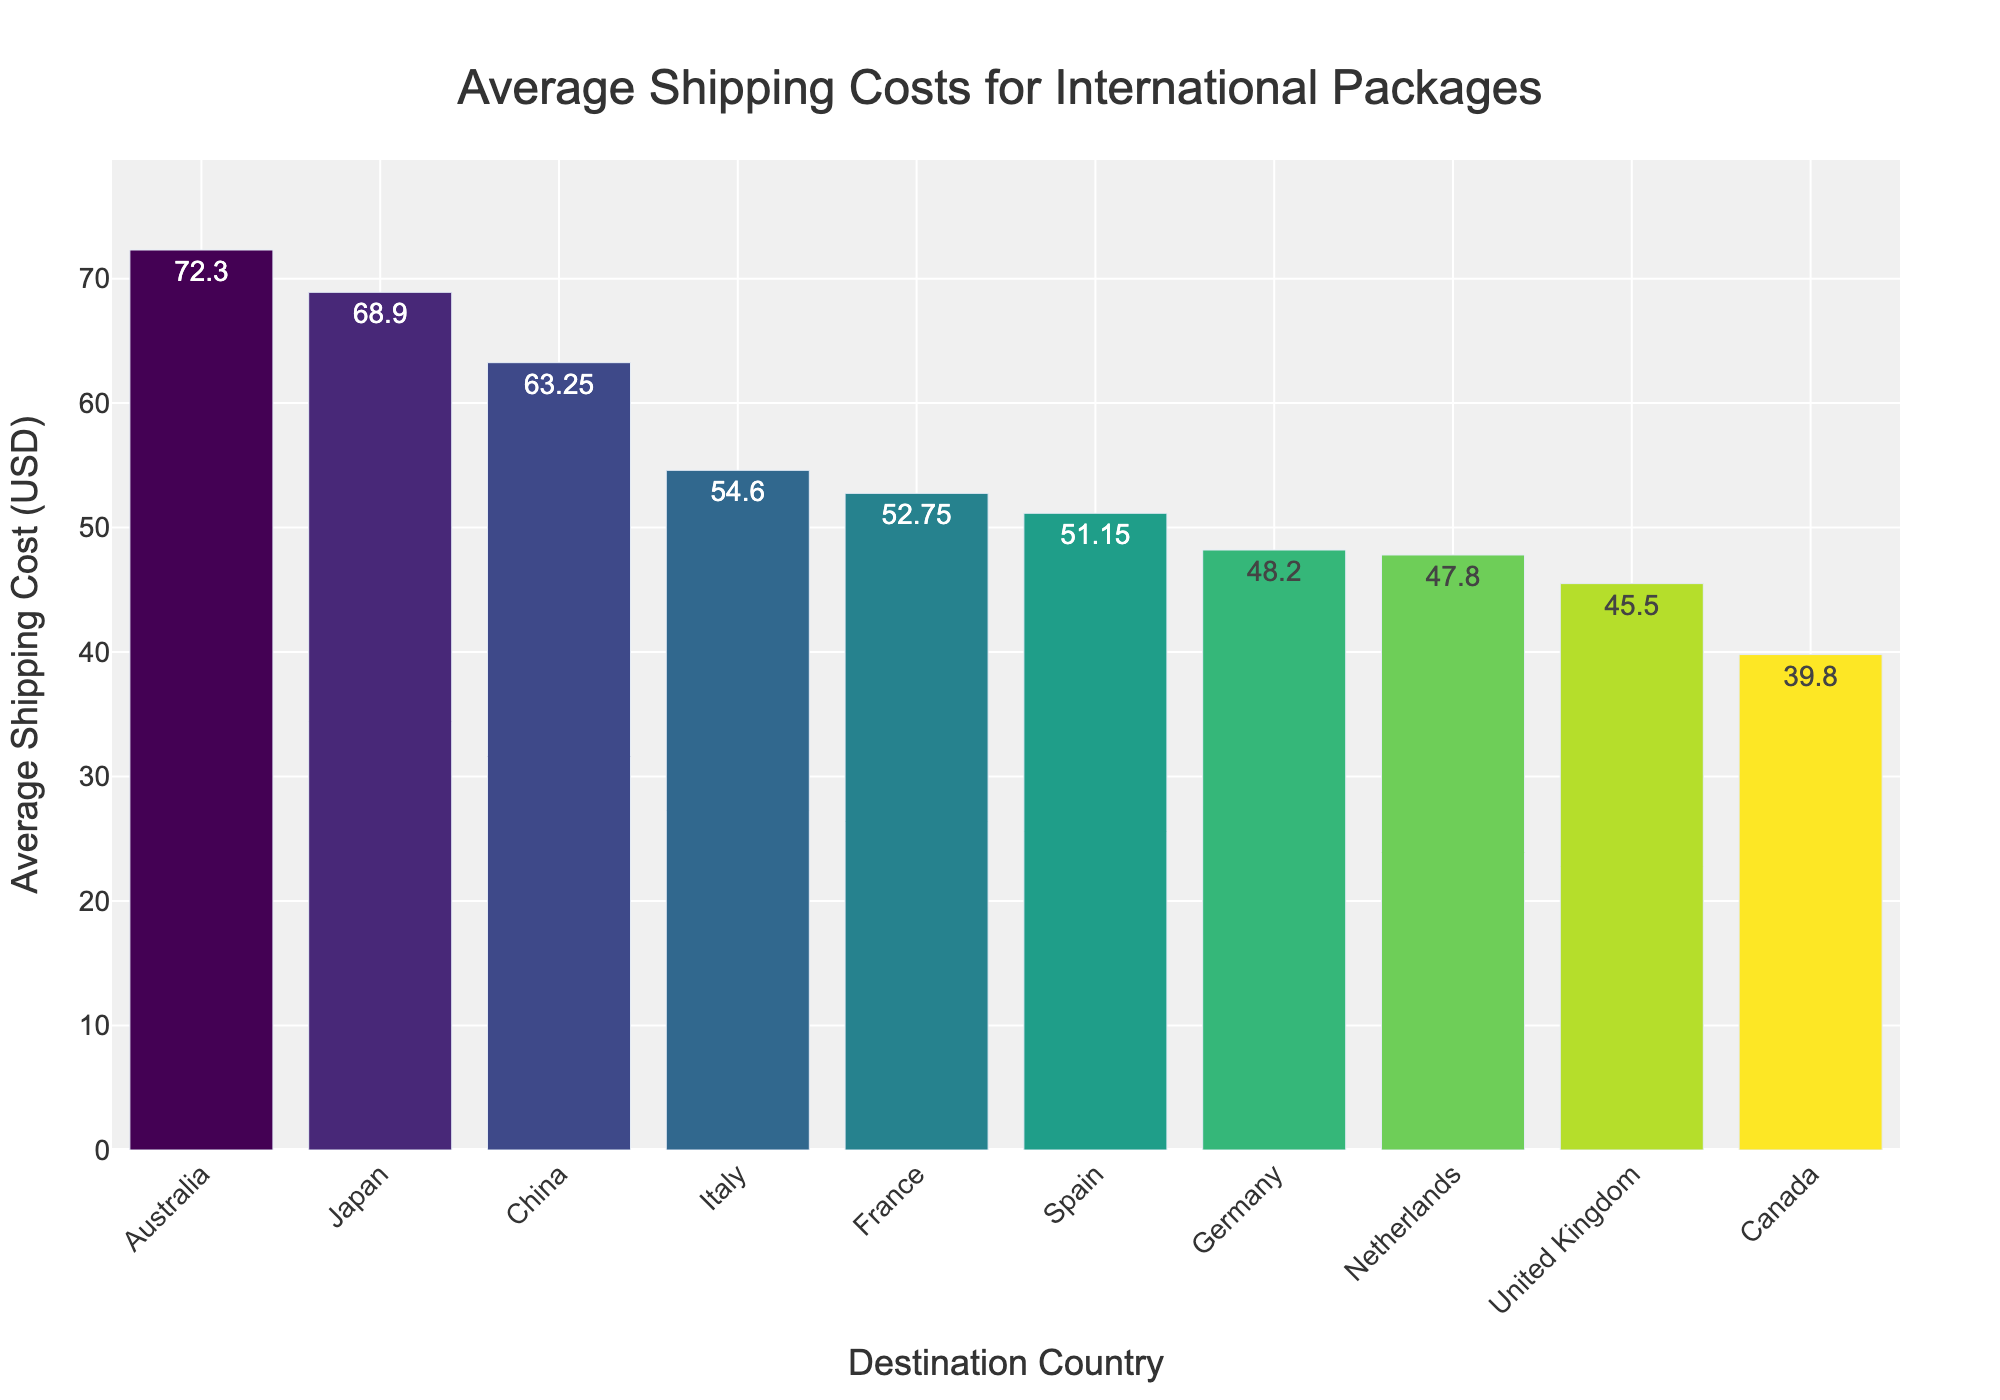What is the average shipping cost to Australia? The bar for Australia shows an average shipping cost of 72.30 USD.
Answer: 72.30 USD Which destination has the lowest average shipping cost? The bar for Canada is the shortest, indicating the lowest average shipping cost.
Answer: Canada How much more expensive is shipping to Japan compared to the United Kingdom? The bar for Japan is at 68.90 USD and the bar for the United Kingdom is at 45.50 USD. The difference is 68.90 - 45.50.
Answer: 23.40 USD What is the total average shipping cost for France and Germany combined? The bar for France shows 52.75 USD and for Germany 48.20 USD. The total is 52.75 + 48.20.
Answer: 100.95 USD How does the shipping cost to China compare with shipping to the Netherlands? The bar for China is at 63.25 USD while the bar for the Netherlands is at 47.80 USD. China is more expensive.
Answer: China is more expensive What is the average shipping cost across all listed destinations? Sum all average shipping costs (45.50 + 52.75 + 48.20 + 68.90 + 72.30 + 39.80 + 54.60 + 51.15 + 47.80 + 63.25) and divide by 10.
Answer: 54.83 USD Which country has the most similar shipping cost to Italy? Italy's bar shows 54.60 USD. France with 52.75 USD is the closest.
Answer: France How much less is the shipping cost to Canada compared to Australia? The bar for Canada is at 39.80 USD and for Australia it is at 72.30 USD. The difference is 72.30 - 39.80.
Answer: 32.50 USD Is the average shipping cost to Germany higher or lower than to Spain? The bar for Germany is at 48.20 USD whereas the bar for Spain is at 51.15 USD. Germany is lower.
Answer: Lower 